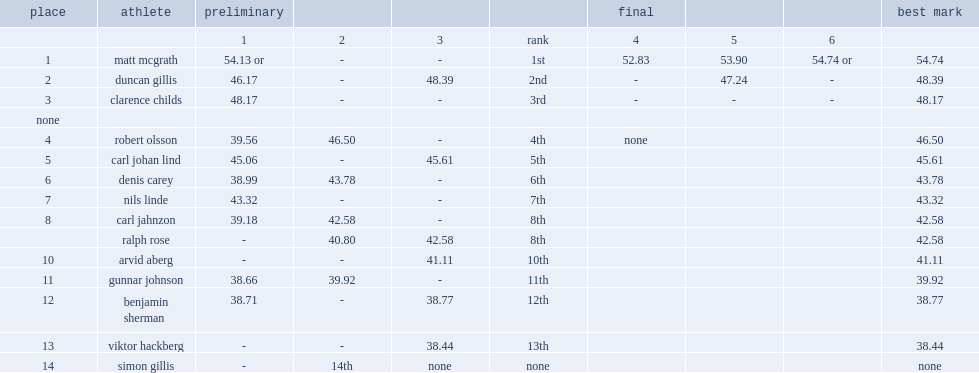What is the final result of matt mcgrath? 54.74 or. 